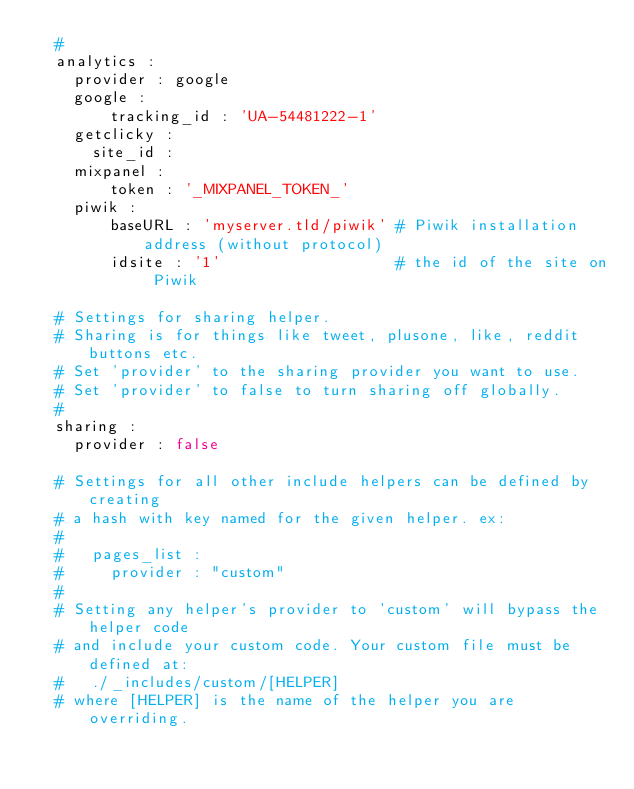Convert code to text. <code><loc_0><loc_0><loc_500><loc_500><_YAML_>  #        
  analytics :
    provider : google 
    google : 
        tracking_id : 'UA-54481222-1'
    getclicky :
      site_id : 
    mixpanel :
        token : '_MIXPANEL_TOKEN_'
    piwik :
        baseURL : 'myserver.tld/piwik' # Piwik installation address (without protocol)
        idsite : '1'                   # the id of the site on Piwik

  # Settings for sharing helper. 
  # Sharing is for things like tweet, plusone, like, reddit buttons etc.
  # Set 'provider' to the sharing provider you want to use.
  # Set 'provider' to false to turn sharing off globally.
  #
  sharing :
    provider : false
    
  # Settings for all other include helpers can be defined by creating 
  # a hash with key named for the given helper. ex:
  #
  #   pages_list :
  #     provider : "custom"   
  #
  # Setting any helper's provider to 'custom' will bypass the helper code
  # and include your custom code. Your custom file must be defined at:
  #   ./_includes/custom/[HELPER]
  # where [HELPER] is the name of the helper you are overriding.
  
</code> 